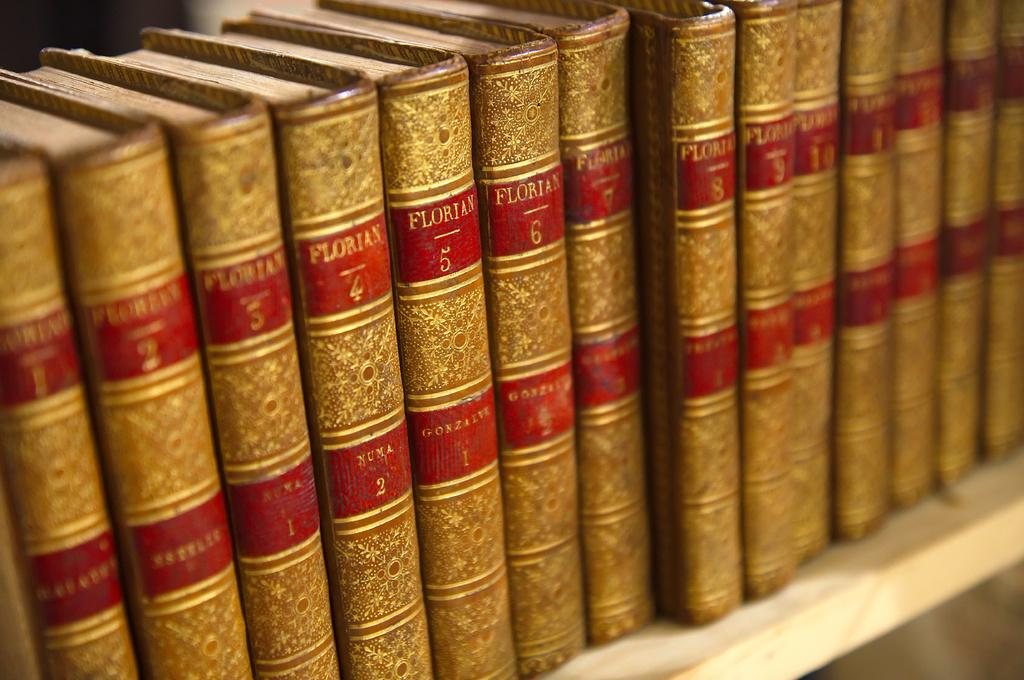<image>
Create a compact narrative representing the image presented. Gold and Red books standing up next to each other with Florian written on them. 